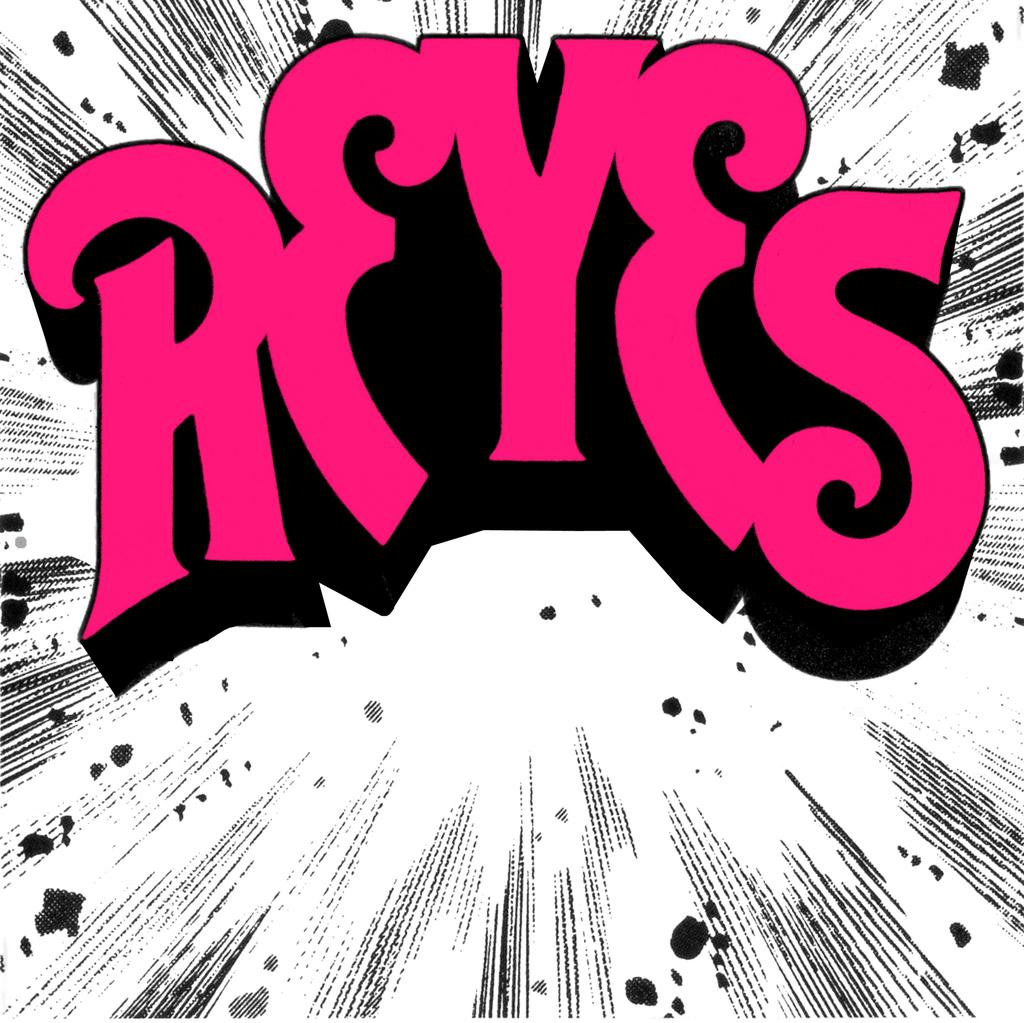Provide a one-sentence caption for the provided image. A graphic of REYES in pink sits atop a black and white background. 